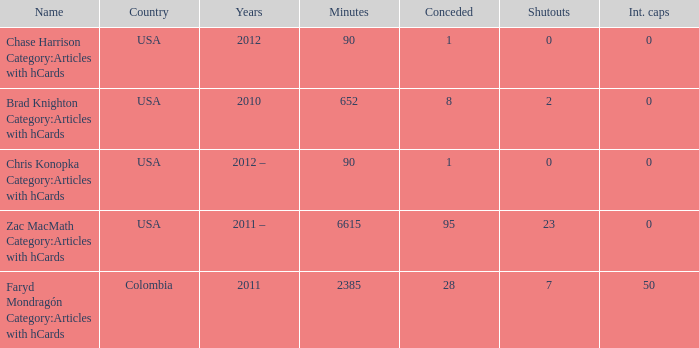When  chris konopka category:articles with hcards is the name what is the year? 2012 –. 